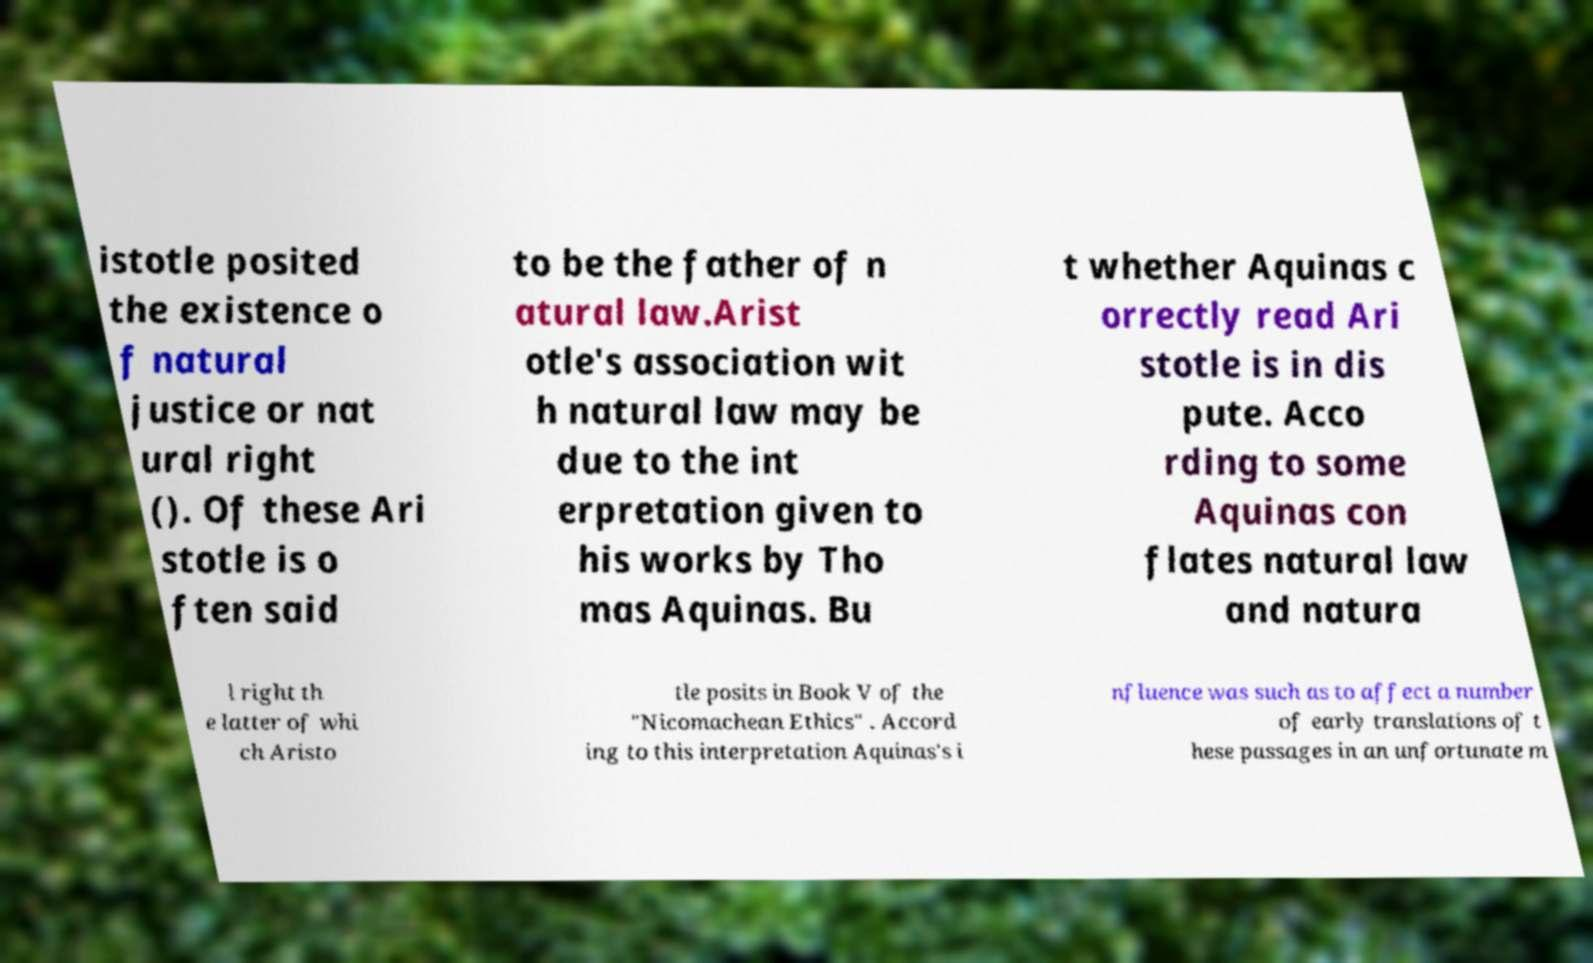Could you assist in decoding the text presented in this image and type it out clearly? istotle posited the existence o f natural justice or nat ural right (). Of these Ari stotle is o ften said to be the father of n atural law.Arist otle's association wit h natural law may be due to the int erpretation given to his works by Tho mas Aquinas. Bu t whether Aquinas c orrectly read Ari stotle is in dis pute. Acco rding to some Aquinas con flates natural law and natura l right th e latter of whi ch Aristo tle posits in Book V of the "Nicomachean Ethics" . Accord ing to this interpretation Aquinas's i nfluence was such as to affect a number of early translations of t hese passages in an unfortunate m 